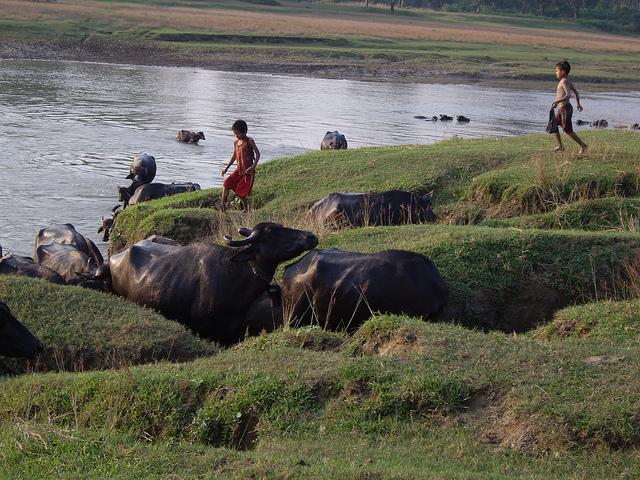Is there any water?
Be succinct. Yes. Why does the grass in the foreground appear darker than that in the background?
Give a very brief answer. Newer. Are they  having fun?
Short answer required. Yes. Is this in America?
Answer briefly. No. What type of animals are in the water?
Write a very short answer. Water buffalo. Where is this?
Write a very short answer. Africa. What animals are in the water?
Write a very short answer. Cows. How many children are in the photo?
Short answer required. 2. What is the bull laying on?
Write a very short answer. Grass. 